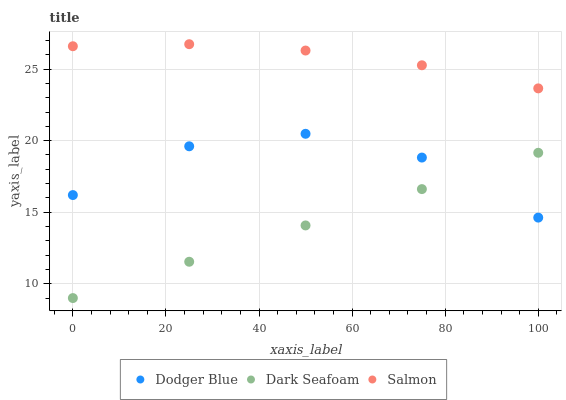Does Dark Seafoam have the minimum area under the curve?
Answer yes or no. Yes. Does Salmon have the maximum area under the curve?
Answer yes or no. Yes. Does Dodger Blue have the minimum area under the curve?
Answer yes or no. No. Does Dodger Blue have the maximum area under the curve?
Answer yes or no. No. Is Dark Seafoam the smoothest?
Answer yes or no. Yes. Is Dodger Blue the roughest?
Answer yes or no. Yes. Is Dodger Blue the smoothest?
Answer yes or no. No. Is Dark Seafoam the roughest?
Answer yes or no. No. Does Dark Seafoam have the lowest value?
Answer yes or no. Yes. Does Dodger Blue have the lowest value?
Answer yes or no. No. Does Salmon have the highest value?
Answer yes or no. Yes. Does Dodger Blue have the highest value?
Answer yes or no. No. Is Dodger Blue less than Salmon?
Answer yes or no. Yes. Is Salmon greater than Dodger Blue?
Answer yes or no. Yes. Does Dodger Blue intersect Dark Seafoam?
Answer yes or no. Yes. Is Dodger Blue less than Dark Seafoam?
Answer yes or no. No. Is Dodger Blue greater than Dark Seafoam?
Answer yes or no. No. Does Dodger Blue intersect Salmon?
Answer yes or no. No. 